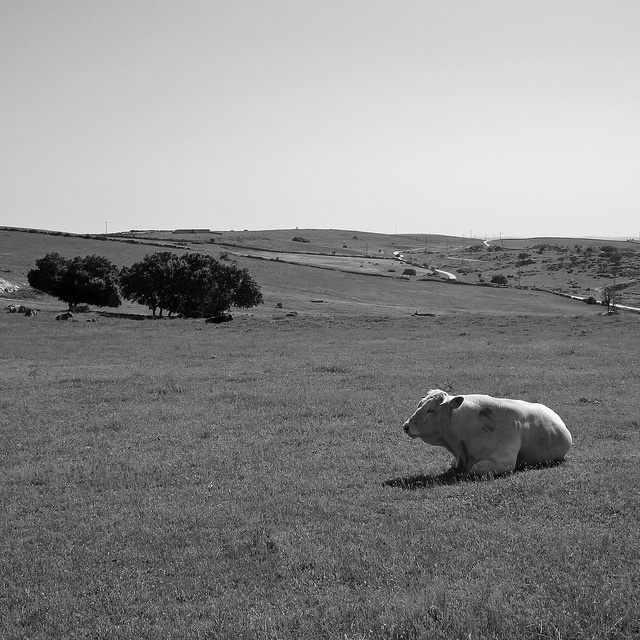Describe the objects in this image and their specific colors. I can see cow in darkgray, black, gray, and lightgray tones, cow in black, gray, and darkgray tones, and cow in black, gray, and darkgray tones in this image. 